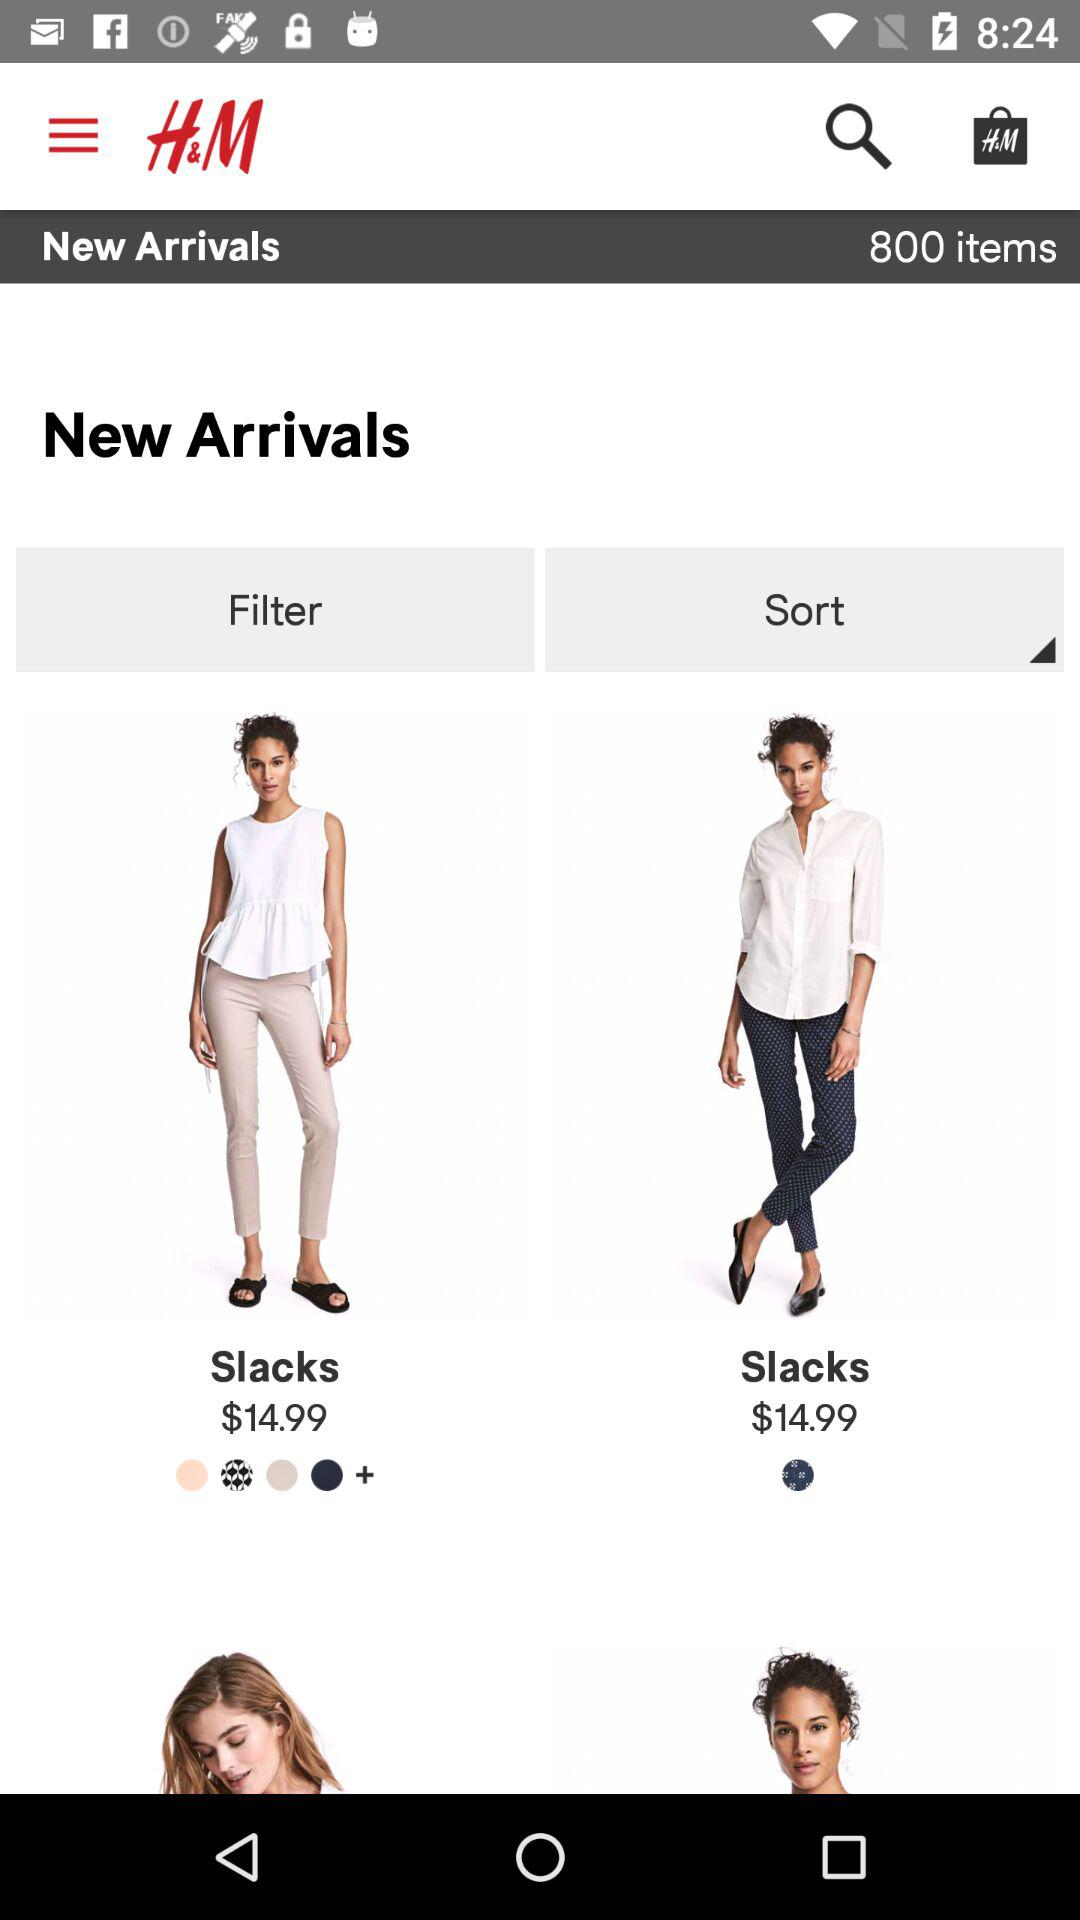How many items are there in new arrivals? There are 800 items in new arrivals. 